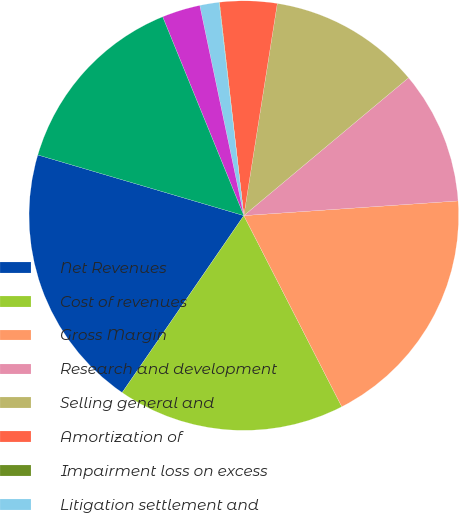<chart> <loc_0><loc_0><loc_500><loc_500><pie_chart><fcel>Net Revenues<fcel>Cost of revenues<fcel>Gross Margin<fcel>Research and development<fcel>Selling general and<fcel>Amortization of<fcel>Impairment loss on excess<fcel>Litigation settlement and<fcel>Write-off of acquired<fcel>Operating Income<nl><fcel>19.97%<fcel>17.12%<fcel>18.55%<fcel>10.0%<fcel>11.42%<fcel>4.3%<fcel>0.03%<fcel>1.45%<fcel>2.88%<fcel>14.27%<nl></chart> 